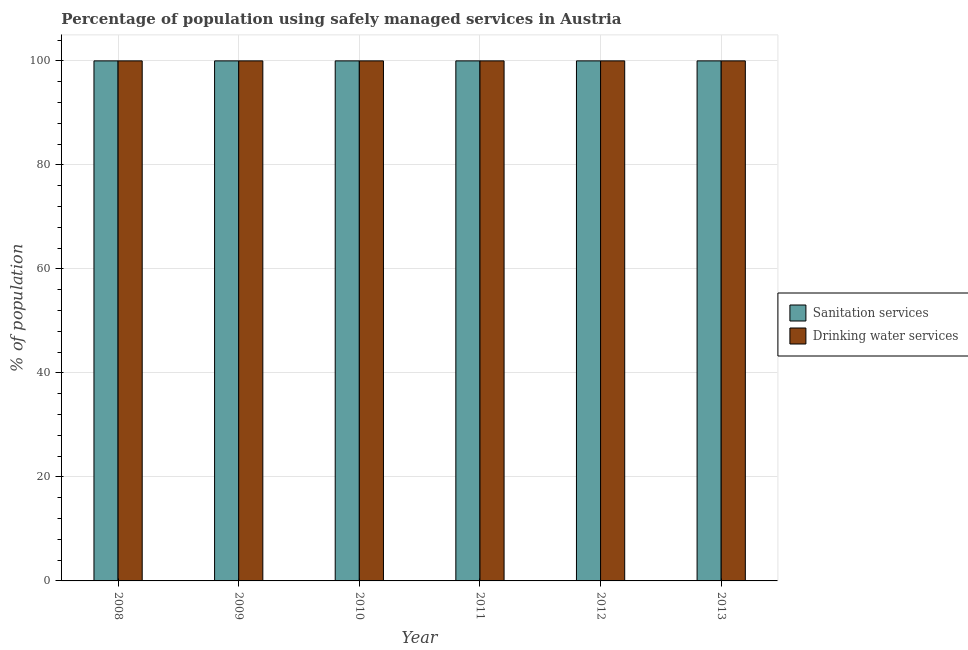Are the number of bars on each tick of the X-axis equal?
Offer a terse response. Yes. How many bars are there on the 6th tick from the right?
Provide a short and direct response. 2. What is the percentage of population who used sanitation services in 2012?
Provide a short and direct response. 100. Across all years, what is the maximum percentage of population who used sanitation services?
Make the answer very short. 100. Across all years, what is the minimum percentage of population who used sanitation services?
Offer a terse response. 100. In which year was the percentage of population who used sanitation services maximum?
Offer a very short reply. 2008. What is the total percentage of population who used sanitation services in the graph?
Ensure brevity in your answer.  600. What is the difference between the percentage of population who used drinking water services in 2011 and that in 2012?
Offer a very short reply. 0. What is the ratio of the percentage of population who used sanitation services in 2009 to that in 2012?
Provide a short and direct response. 1. Is the difference between the percentage of population who used drinking water services in 2008 and 2012 greater than the difference between the percentage of population who used sanitation services in 2008 and 2012?
Give a very brief answer. No. What is the difference between the highest and the second highest percentage of population who used drinking water services?
Your response must be concise. 0. Is the sum of the percentage of population who used sanitation services in 2012 and 2013 greater than the maximum percentage of population who used drinking water services across all years?
Provide a succinct answer. Yes. What does the 1st bar from the left in 2010 represents?
Your answer should be very brief. Sanitation services. What does the 1st bar from the right in 2008 represents?
Offer a terse response. Drinking water services. How many bars are there?
Offer a terse response. 12. How many years are there in the graph?
Offer a very short reply. 6. What is the difference between two consecutive major ticks on the Y-axis?
Provide a short and direct response. 20. Does the graph contain any zero values?
Your answer should be compact. No. Does the graph contain grids?
Keep it short and to the point. Yes. Where does the legend appear in the graph?
Offer a terse response. Center right. What is the title of the graph?
Give a very brief answer. Percentage of population using safely managed services in Austria. Does "Quasi money growth" appear as one of the legend labels in the graph?
Provide a short and direct response. No. What is the label or title of the X-axis?
Give a very brief answer. Year. What is the label or title of the Y-axis?
Your answer should be compact. % of population. What is the % of population in Sanitation services in 2009?
Your response must be concise. 100. What is the % of population of Drinking water services in 2009?
Your answer should be compact. 100. What is the % of population of Sanitation services in 2010?
Your answer should be very brief. 100. What is the % of population in Drinking water services in 2011?
Provide a short and direct response. 100. What is the % of population of Sanitation services in 2012?
Ensure brevity in your answer.  100. What is the % of population of Drinking water services in 2012?
Your response must be concise. 100. What is the % of population in Sanitation services in 2013?
Provide a succinct answer. 100. Across all years, what is the maximum % of population of Sanitation services?
Offer a terse response. 100. Across all years, what is the minimum % of population of Sanitation services?
Your answer should be very brief. 100. What is the total % of population in Sanitation services in the graph?
Offer a very short reply. 600. What is the total % of population in Drinking water services in the graph?
Provide a short and direct response. 600. What is the difference between the % of population in Sanitation services in 2008 and that in 2009?
Your answer should be compact. 0. What is the difference between the % of population in Sanitation services in 2008 and that in 2010?
Offer a very short reply. 0. What is the difference between the % of population of Drinking water services in 2008 and that in 2011?
Offer a very short reply. 0. What is the difference between the % of population of Sanitation services in 2008 and that in 2012?
Offer a very short reply. 0. What is the difference between the % of population of Drinking water services in 2008 and that in 2012?
Your response must be concise. 0. What is the difference between the % of population in Sanitation services in 2008 and that in 2013?
Your answer should be very brief. 0. What is the difference between the % of population in Drinking water services in 2008 and that in 2013?
Offer a terse response. 0. What is the difference between the % of population of Drinking water services in 2009 and that in 2010?
Offer a very short reply. 0. What is the difference between the % of population in Sanitation services in 2009 and that in 2011?
Offer a terse response. 0. What is the difference between the % of population in Drinking water services in 2011 and that in 2012?
Your response must be concise. 0. What is the difference between the % of population in Sanitation services in 2011 and that in 2013?
Provide a short and direct response. 0. What is the difference between the % of population in Sanitation services in 2012 and that in 2013?
Offer a terse response. 0. What is the difference between the % of population in Drinking water services in 2012 and that in 2013?
Your response must be concise. 0. What is the difference between the % of population of Sanitation services in 2008 and the % of population of Drinking water services in 2010?
Keep it short and to the point. 0. What is the difference between the % of population of Sanitation services in 2008 and the % of population of Drinking water services in 2011?
Give a very brief answer. 0. What is the difference between the % of population in Sanitation services in 2008 and the % of population in Drinking water services in 2013?
Your answer should be very brief. 0. What is the difference between the % of population of Sanitation services in 2009 and the % of population of Drinking water services in 2010?
Provide a succinct answer. 0. What is the difference between the % of population of Sanitation services in 2009 and the % of population of Drinking water services in 2011?
Your response must be concise. 0. What is the difference between the % of population of Sanitation services in 2009 and the % of population of Drinking water services in 2012?
Provide a succinct answer. 0. What is the difference between the % of population in Sanitation services in 2009 and the % of population in Drinking water services in 2013?
Make the answer very short. 0. What is the difference between the % of population of Sanitation services in 2010 and the % of population of Drinking water services in 2011?
Your answer should be compact. 0. What is the difference between the % of population of Sanitation services in 2010 and the % of population of Drinking water services in 2012?
Your answer should be very brief. 0. What is the difference between the % of population in Sanitation services in 2011 and the % of population in Drinking water services in 2012?
Make the answer very short. 0. What is the difference between the % of population in Sanitation services in 2012 and the % of population in Drinking water services in 2013?
Your answer should be very brief. 0. What is the average % of population in Sanitation services per year?
Your response must be concise. 100. What is the average % of population of Drinking water services per year?
Give a very brief answer. 100. In the year 2010, what is the difference between the % of population in Sanitation services and % of population in Drinking water services?
Make the answer very short. 0. In the year 2012, what is the difference between the % of population of Sanitation services and % of population of Drinking water services?
Keep it short and to the point. 0. What is the ratio of the % of population of Drinking water services in 2008 to that in 2009?
Give a very brief answer. 1. What is the ratio of the % of population of Sanitation services in 2008 to that in 2010?
Your answer should be very brief. 1. What is the ratio of the % of population of Sanitation services in 2008 to that in 2011?
Offer a terse response. 1. What is the ratio of the % of population of Sanitation services in 2008 to that in 2012?
Offer a terse response. 1. What is the ratio of the % of population in Drinking water services in 2008 to that in 2012?
Ensure brevity in your answer.  1. What is the ratio of the % of population of Sanitation services in 2008 to that in 2013?
Provide a short and direct response. 1. What is the ratio of the % of population of Drinking water services in 2009 to that in 2010?
Offer a terse response. 1. What is the ratio of the % of population of Drinking water services in 2009 to that in 2012?
Keep it short and to the point. 1. What is the ratio of the % of population in Drinking water services in 2009 to that in 2013?
Make the answer very short. 1. What is the ratio of the % of population in Sanitation services in 2010 to that in 2013?
Offer a very short reply. 1. What is the ratio of the % of population of Sanitation services in 2011 to that in 2012?
Offer a very short reply. 1. What is the ratio of the % of population of Drinking water services in 2011 to that in 2012?
Make the answer very short. 1. What is the ratio of the % of population in Sanitation services in 2011 to that in 2013?
Offer a very short reply. 1. What is the ratio of the % of population of Drinking water services in 2012 to that in 2013?
Offer a terse response. 1. 